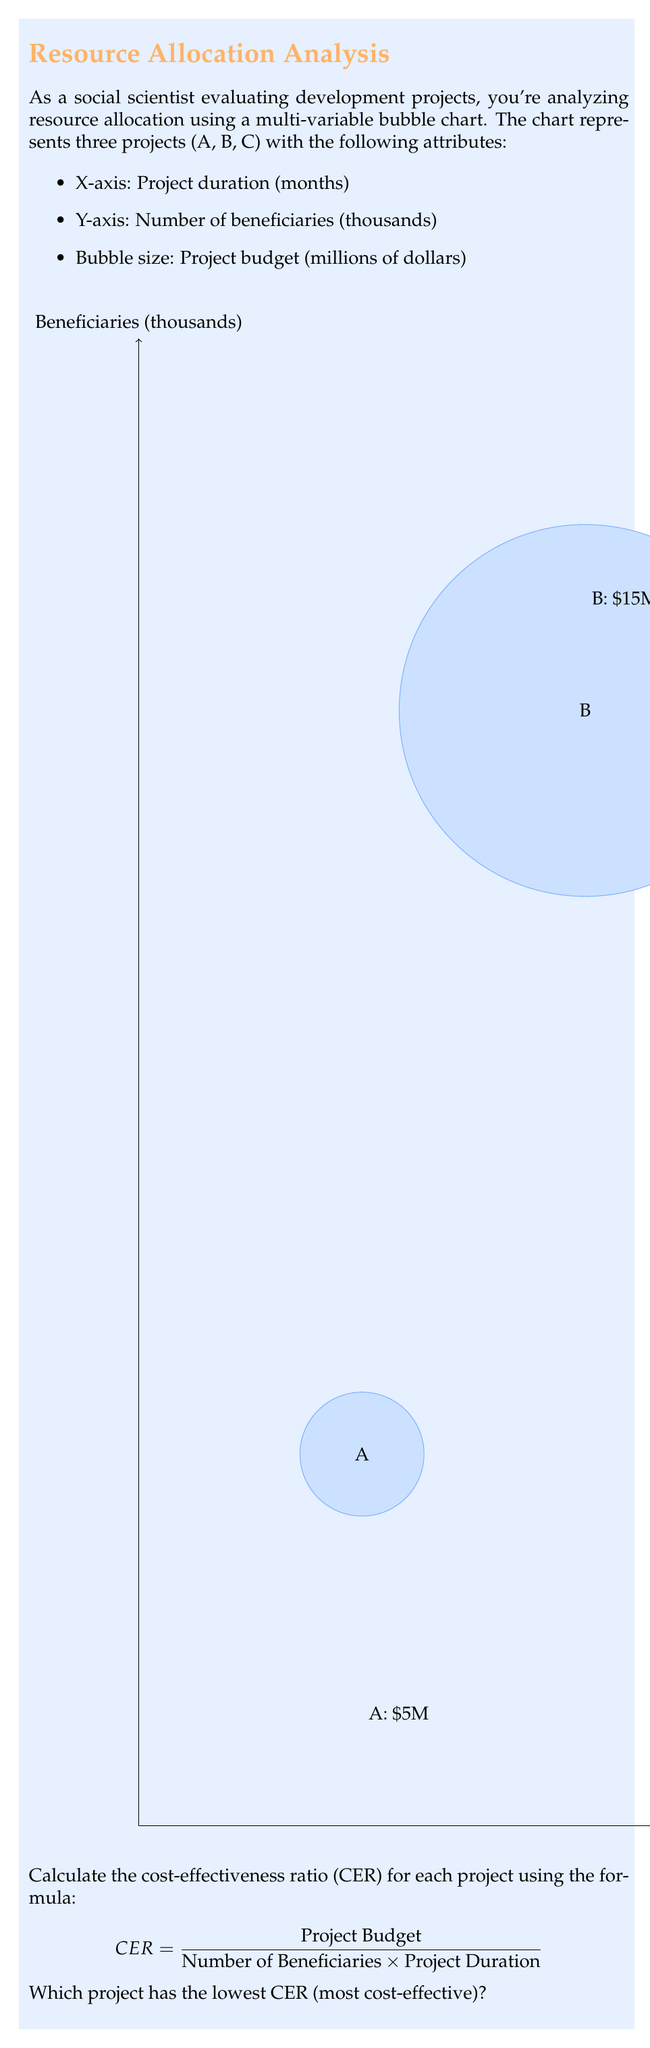Provide a solution to this math problem. To solve this problem, we need to calculate the CER for each project using the given formula. Let's go through it step-by-step:

1. Extract the data for each project:
   Project A: Duration = 6 months, Beneficiaries = 10,000, Budget = $5 million
   Project B: Duration = 12 months, Beneficiaries = 30,000, Budget = $15 million
   Project C: Duration = 18 months, Beneficiaries = 20,000, Budget = $10 million

2. Calculate CER for Project A:
   $$ CER_A = \frac{5,000,000}{10,000 \times 6} = \frac{5,000,000}{60,000} = 83.33 $$

3. Calculate CER for Project B:
   $$ CER_B = \frac{15,000,000}{30,000 \times 12} = \frac{15,000,000}{360,000} = 41.67 $$

4. Calculate CER for Project C:
   $$ CER_C = \frac{10,000,000}{20,000 \times 18} = \frac{10,000,000}{360,000} = 27.78 $$

5. Compare the CER values:
   Project A: 83.33
   Project B: 41.67
   Project C: 27.78

The project with the lowest CER is the most cost-effective, as it represents the lowest cost per beneficiary-month.
Answer: Project C 